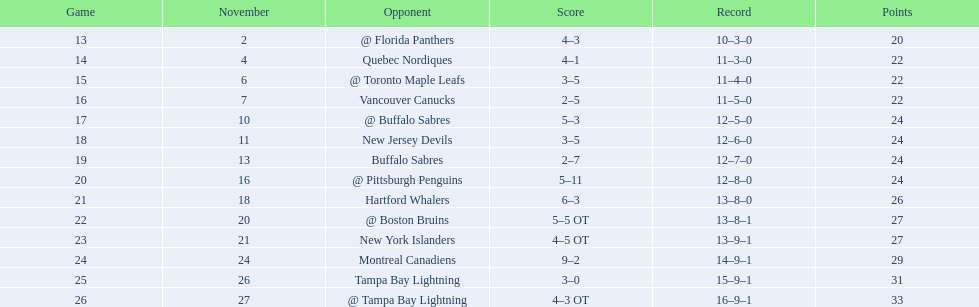What were the final tallies? @ Florida Panthers, 4–3, Quebec Nordiques, 4–1, @ Toronto Maple Leafs, 3–5, Vancouver Canucks, 2–5, @ Buffalo Sabres, 5–3, New Jersey Devils, 3–5, Buffalo Sabres, 2–7, @ Pittsburgh Penguins, 5–11, Hartford Whalers, 6–3, @ Boston Bruins, 5–5 OT, New York Islanders, 4–5 OT, Montreal Canadiens, 9–2, Tampa Bay Lightning, 3–0, @ Tampa Bay Lightning, 4–3 OT. Which score was most similar? New York Islanders, 4–5 OT. Which team held that score? New York Islanders. 